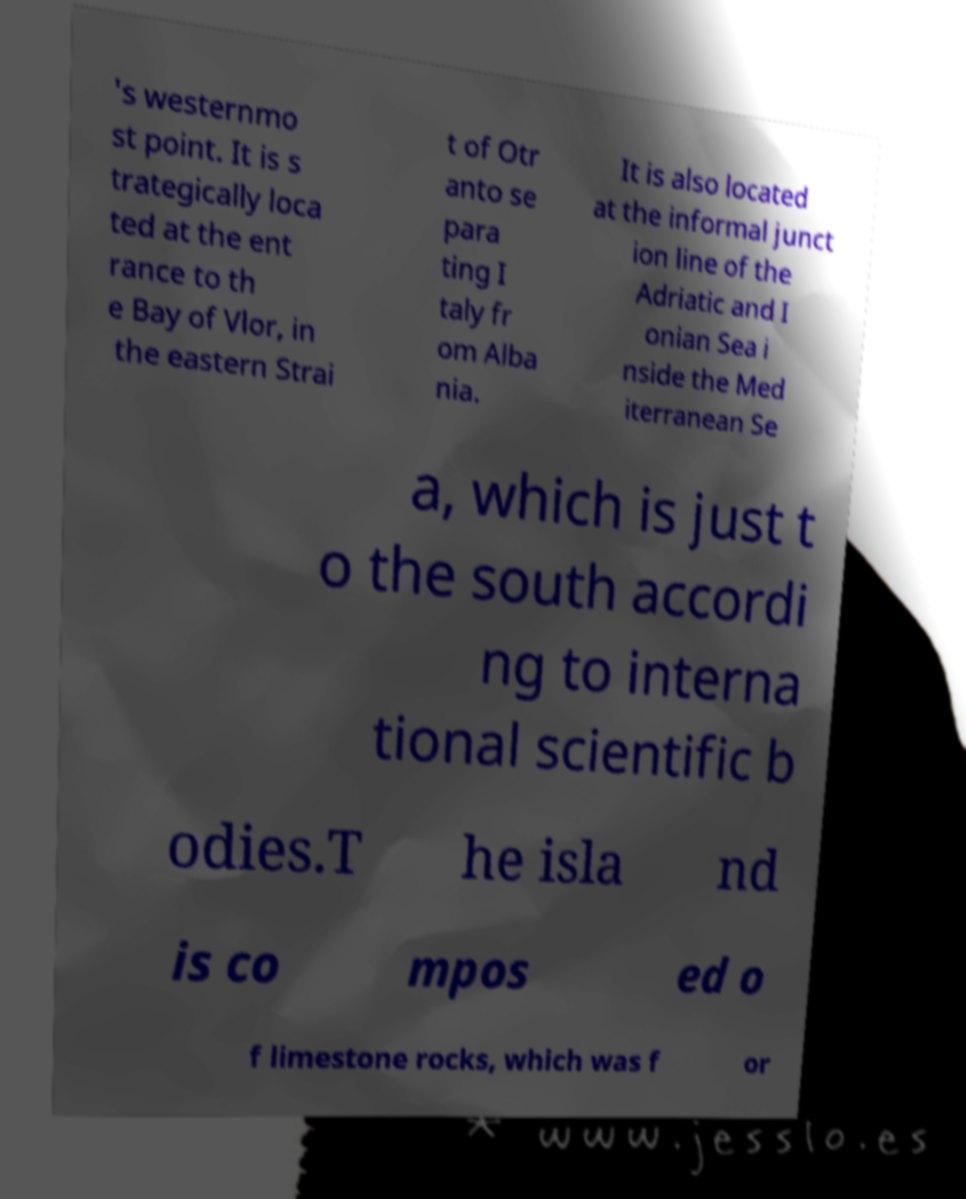Please read and relay the text visible in this image. What does it say? 's westernmo st point. It is s trategically loca ted at the ent rance to th e Bay of Vlor, in the eastern Strai t of Otr anto se para ting I taly fr om Alba nia. It is also located at the informal junct ion line of the Adriatic and I onian Sea i nside the Med iterranean Se a, which is just t o the south accordi ng to interna tional scientific b odies.T he isla nd is co mpos ed o f limestone rocks, which was f or 